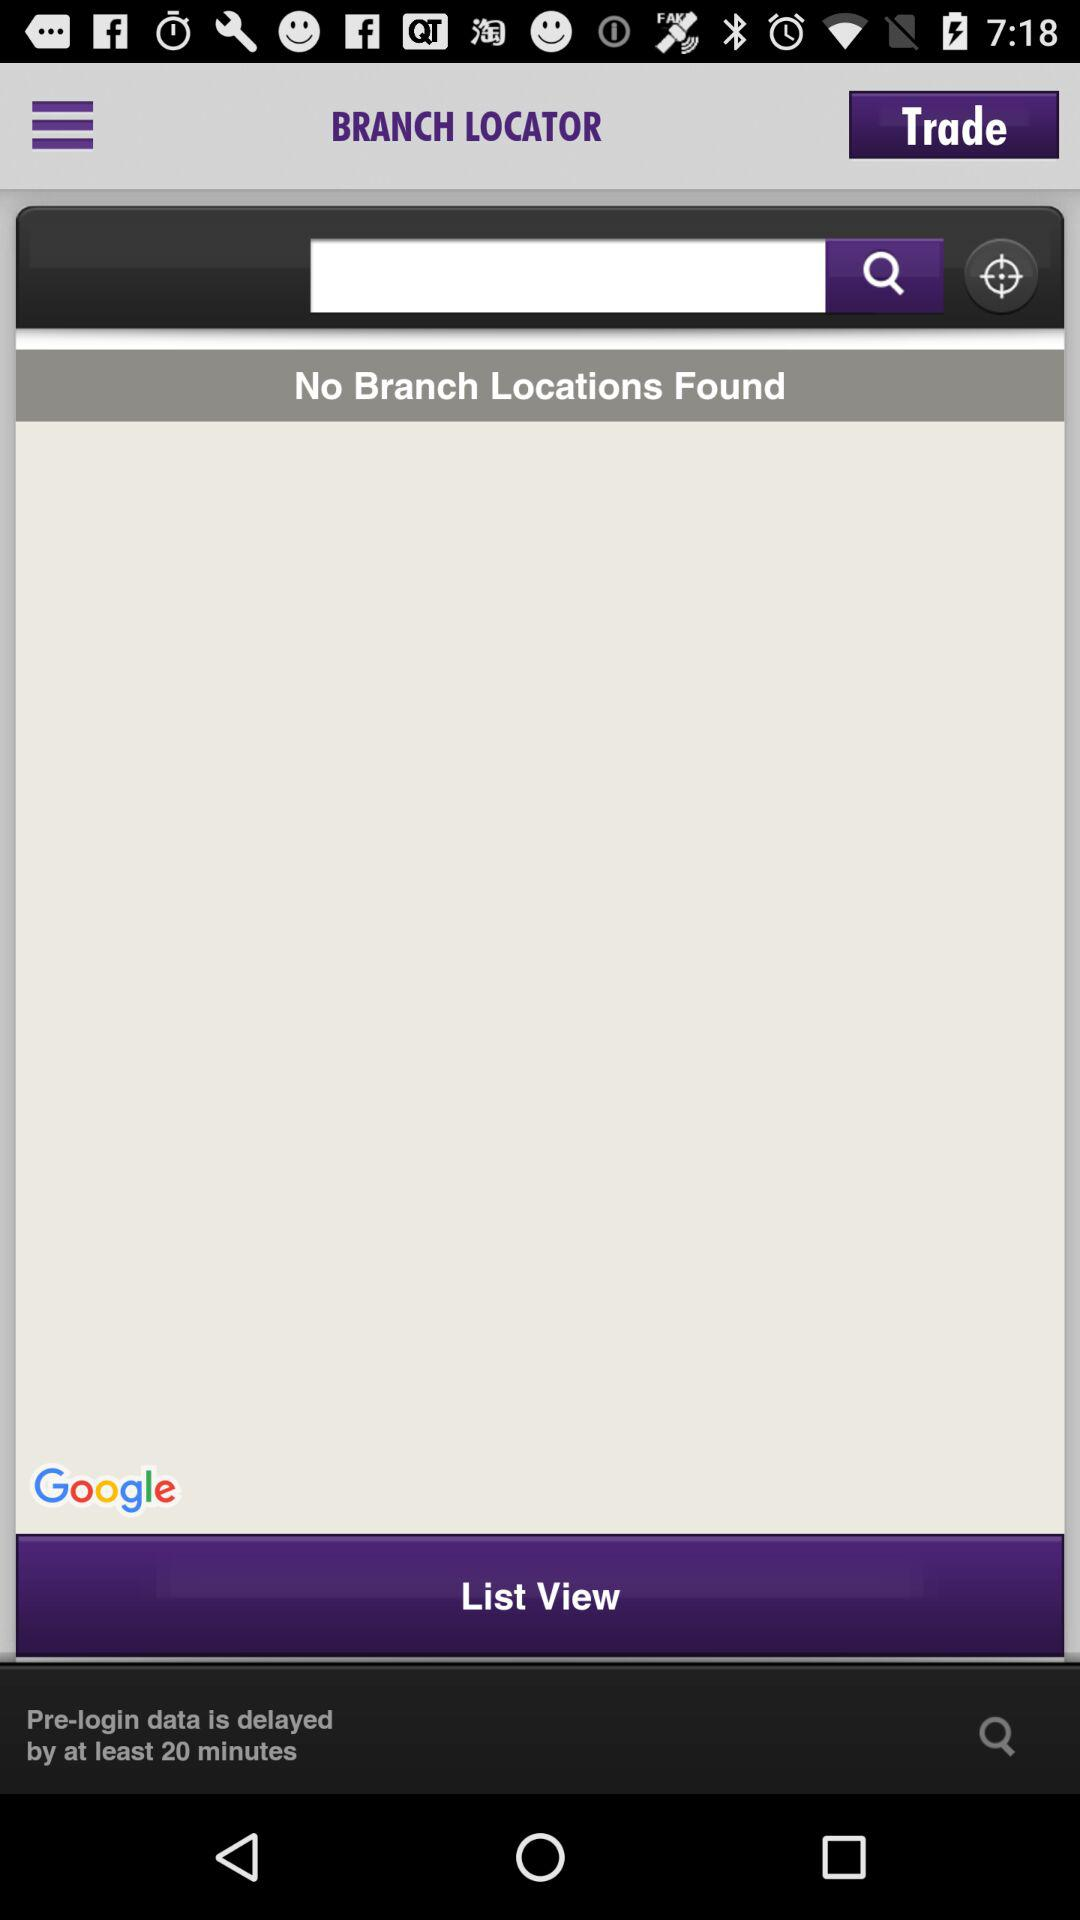By how many minutes is the pre-login data delayed? The pre-login data is delayed by at least 20 minutes. 